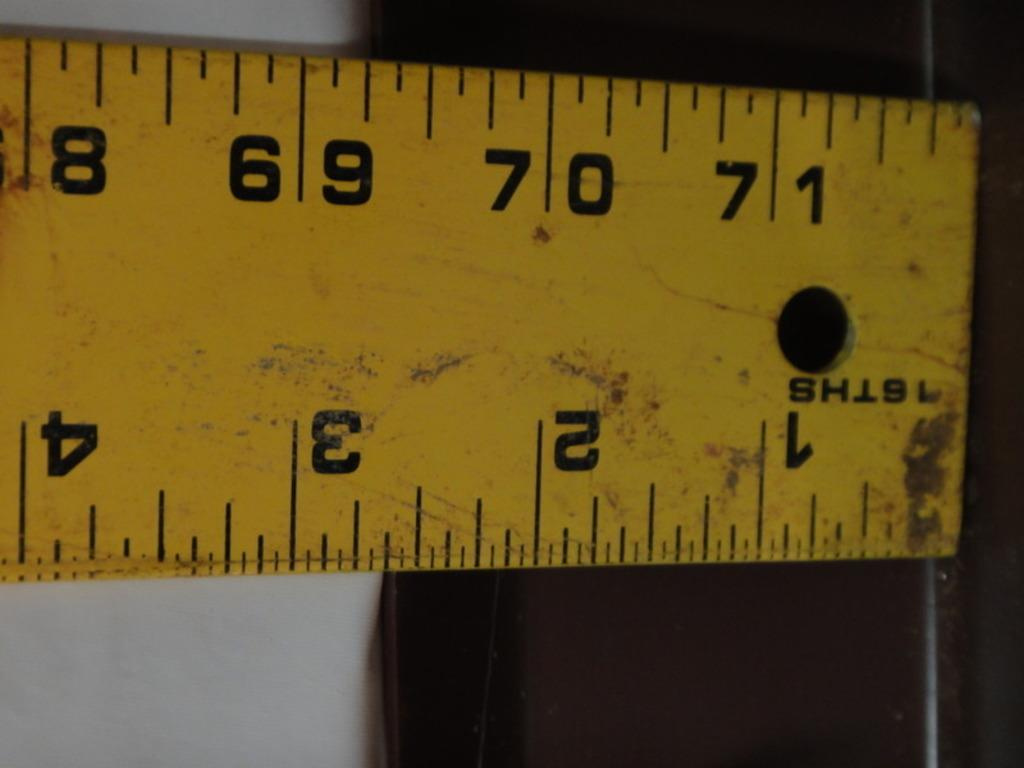<image>
Create a compact narrative representing the image presented. a ruler by ISTHS showing inches and centimeters 